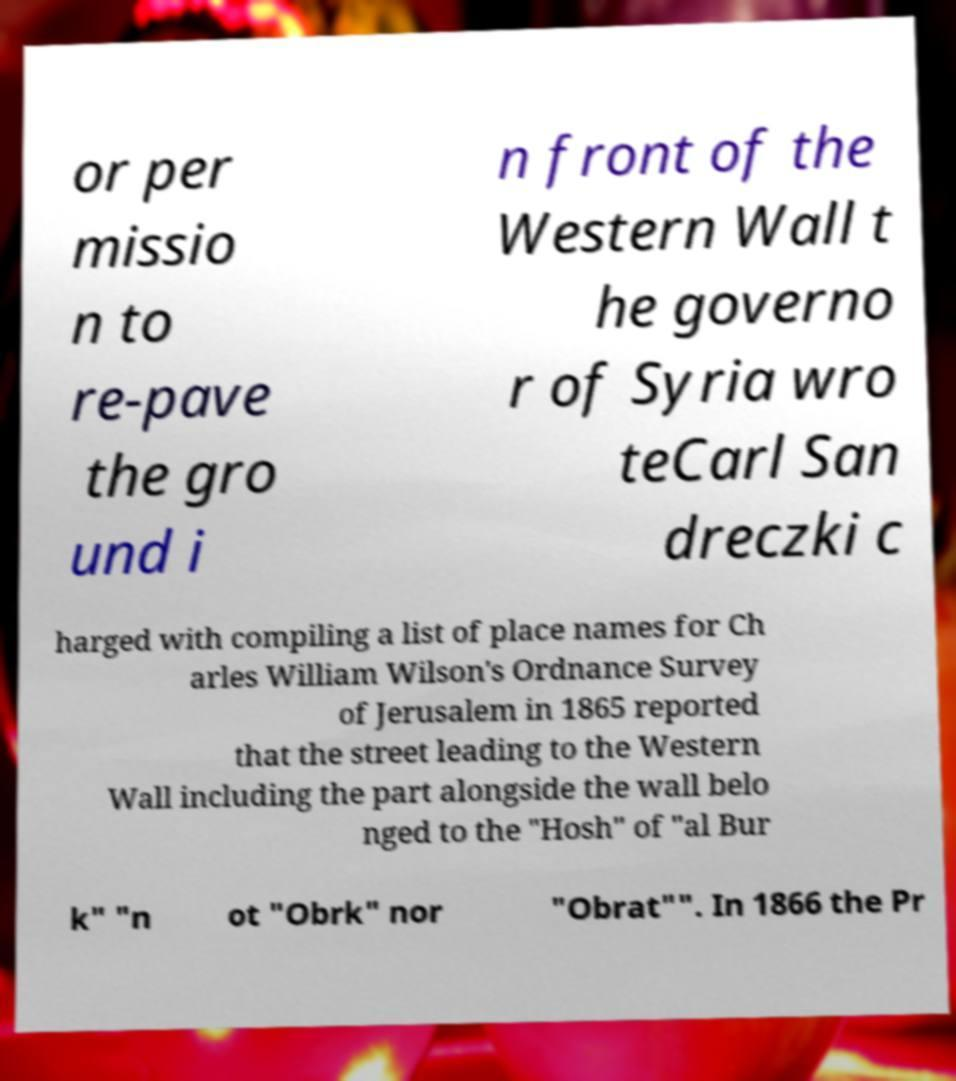There's text embedded in this image that I need extracted. Can you transcribe it verbatim? or per missio n to re-pave the gro und i n front of the Western Wall t he governo r of Syria wro teCarl San dreczki c harged with compiling a list of place names for Ch arles William Wilson's Ordnance Survey of Jerusalem in 1865 reported that the street leading to the Western Wall including the part alongside the wall belo nged to the "Hosh" of "al Bur k" "n ot "Obrk" nor "Obrat"". In 1866 the Pr 